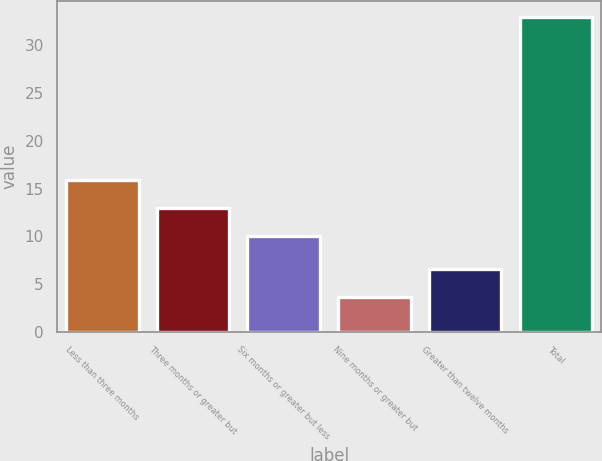Convert chart. <chart><loc_0><loc_0><loc_500><loc_500><bar_chart><fcel>Less than three months<fcel>Three months or greater but<fcel>Six months or greater but less<fcel>Nine months or greater but<fcel>Greater than twelve months<fcel>Total<nl><fcel>15.86<fcel>12.93<fcel>10<fcel>3.66<fcel>6.59<fcel>33<nl></chart> 